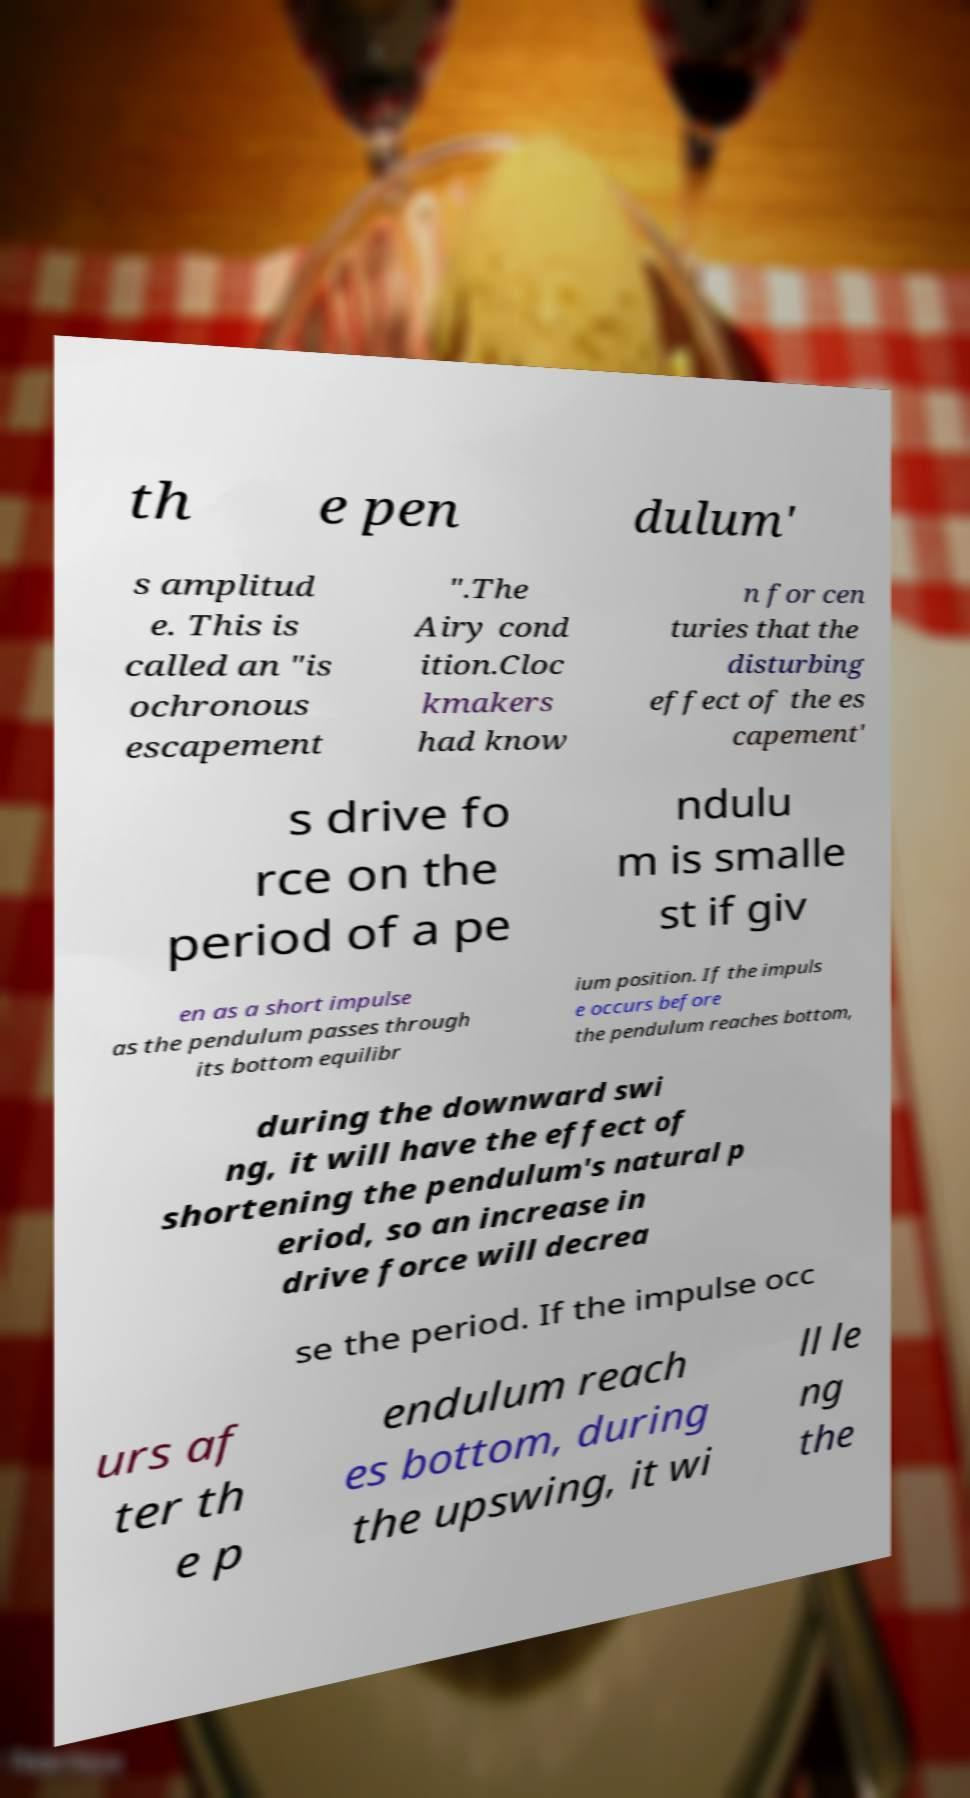Could you extract and type out the text from this image? th e pen dulum' s amplitud e. This is called an "is ochronous escapement ".The Airy cond ition.Cloc kmakers had know n for cen turies that the disturbing effect of the es capement' s drive fo rce on the period of a pe ndulu m is smalle st if giv en as a short impulse as the pendulum passes through its bottom equilibr ium position. If the impuls e occurs before the pendulum reaches bottom, during the downward swi ng, it will have the effect of shortening the pendulum's natural p eriod, so an increase in drive force will decrea se the period. If the impulse occ urs af ter th e p endulum reach es bottom, during the upswing, it wi ll le ng the 